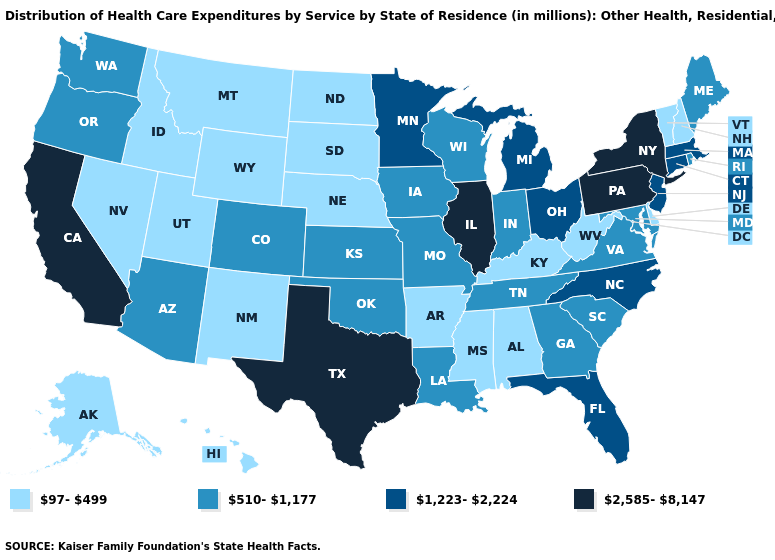What is the value of Mississippi?
Short answer required. 97-499. What is the value of Nevada?
Be succinct. 97-499. What is the highest value in states that border Nebraska?
Short answer required. 510-1,177. Which states have the highest value in the USA?
Concise answer only. California, Illinois, New York, Pennsylvania, Texas. What is the value of South Dakota?
Be succinct. 97-499. Does Vermont have the same value as New Jersey?
Keep it brief. No. Among the states that border Oklahoma , which have the highest value?
Be succinct. Texas. Among the states that border Washington , does Oregon have the lowest value?
Give a very brief answer. No. Which states have the lowest value in the Northeast?
Give a very brief answer. New Hampshire, Vermont. Among the states that border Ohio , which have the lowest value?
Quick response, please. Kentucky, West Virginia. What is the highest value in the USA?
Be succinct. 2,585-8,147. Does Washington have the highest value in the USA?
Write a very short answer. No. Among the states that border North Dakota , which have the highest value?
Keep it brief. Minnesota. Does Wisconsin have a lower value than Minnesota?
Be succinct. Yes. 